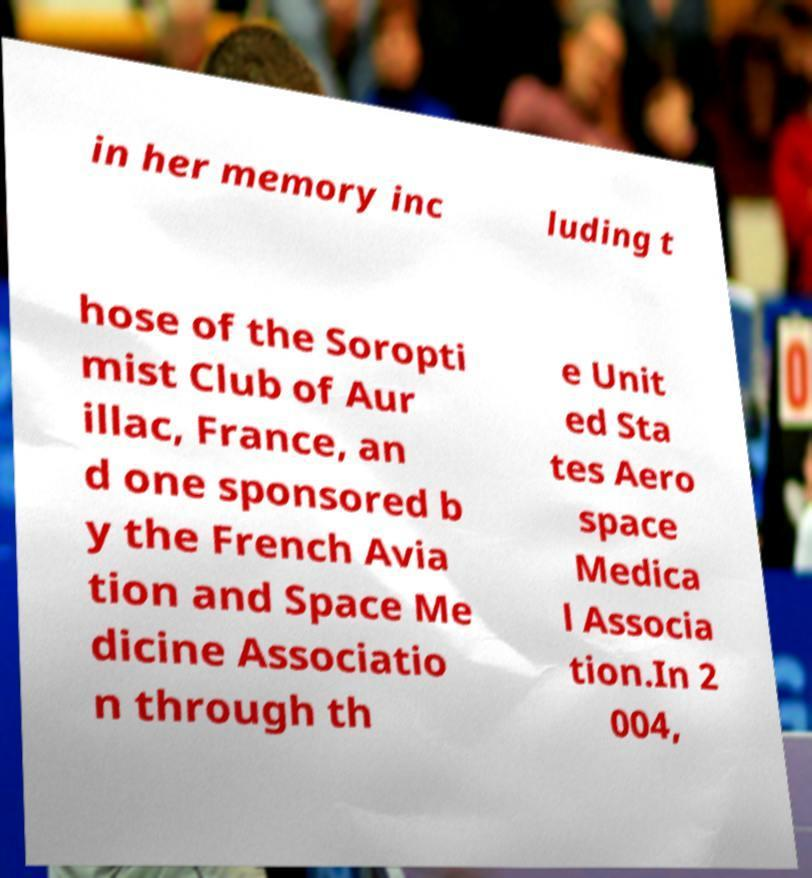Please identify and transcribe the text found in this image. in her memory inc luding t hose of the Soropti mist Club of Aur illac, France, an d one sponsored b y the French Avia tion and Space Me dicine Associatio n through th e Unit ed Sta tes Aero space Medica l Associa tion.In 2 004, 